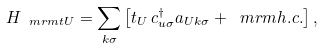Convert formula to latex. <formula><loc_0><loc_0><loc_500><loc_500>H _ { \ m r m { t U } } = \sum _ { k \sigma } \left [ t _ { U } \, c ^ { \dagger } _ { u \sigma } a _ { U k \sigma } + \ m r m { h . c . } \right ] ,</formula> 